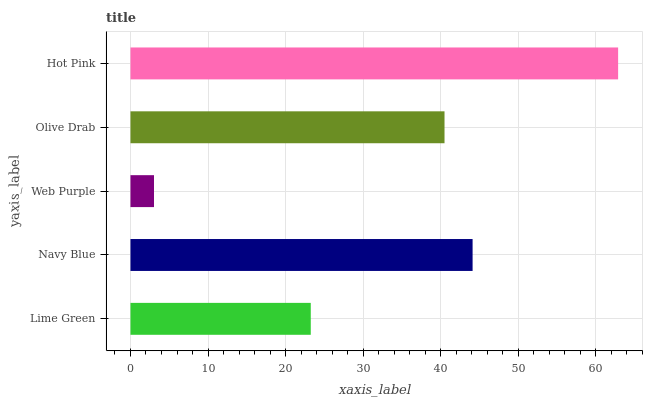Is Web Purple the minimum?
Answer yes or no. Yes. Is Hot Pink the maximum?
Answer yes or no. Yes. Is Navy Blue the minimum?
Answer yes or no. No. Is Navy Blue the maximum?
Answer yes or no. No. Is Navy Blue greater than Lime Green?
Answer yes or no. Yes. Is Lime Green less than Navy Blue?
Answer yes or no. Yes. Is Lime Green greater than Navy Blue?
Answer yes or no. No. Is Navy Blue less than Lime Green?
Answer yes or no. No. Is Olive Drab the high median?
Answer yes or no. Yes. Is Olive Drab the low median?
Answer yes or no. Yes. Is Web Purple the high median?
Answer yes or no. No. Is Hot Pink the low median?
Answer yes or no. No. 